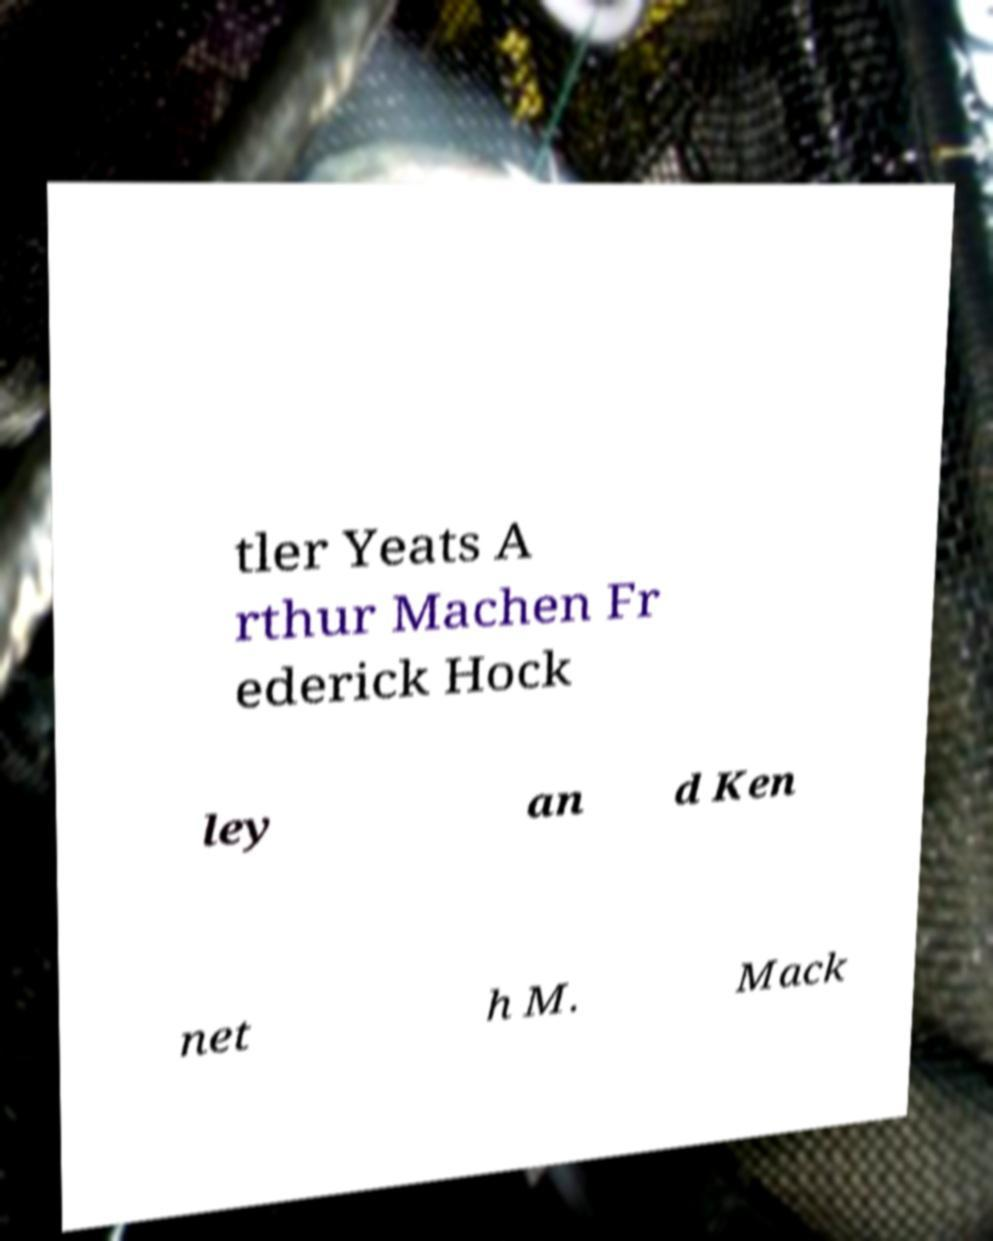There's text embedded in this image that I need extracted. Can you transcribe it verbatim? tler Yeats A rthur Machen Fr ederick Hock ley an d Ken net h M. Mack 